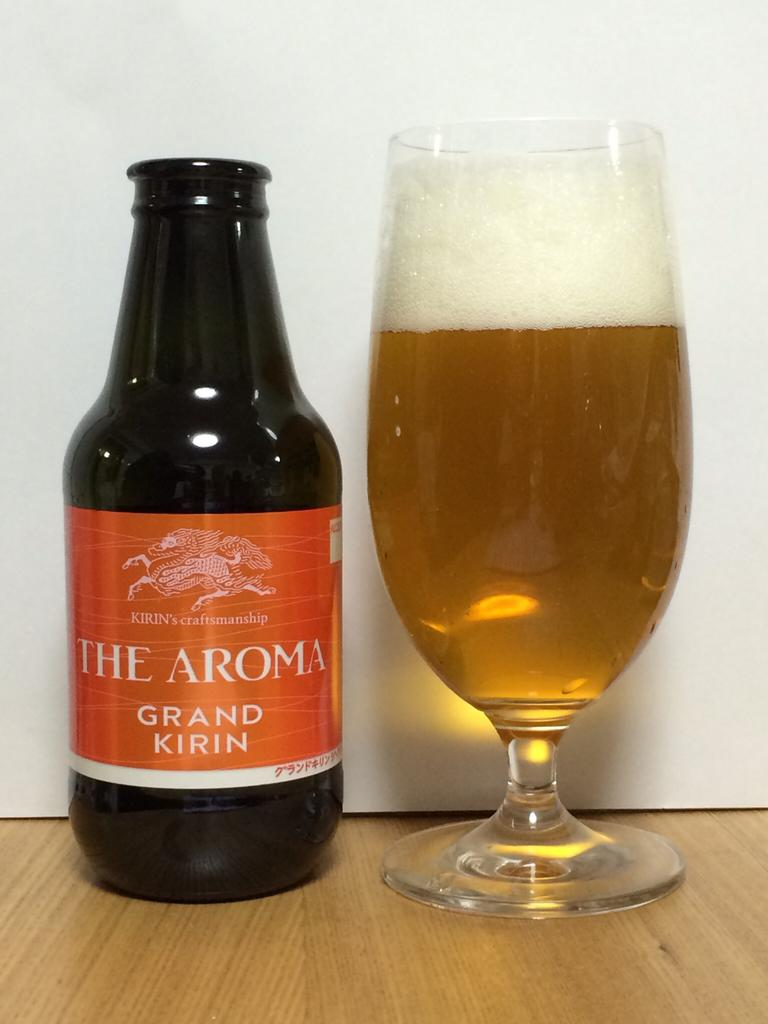<image>
Render a clear and concise summary of the photo. A glass almost full of beer next to a glass bottle of The Aroma Grand Kirin. 